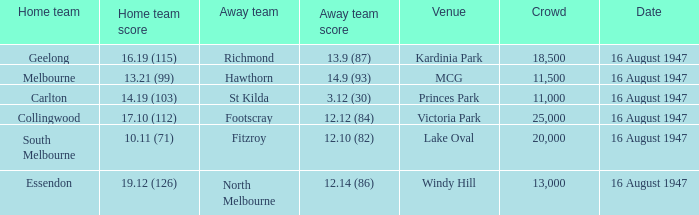What home team has had a crowd bigger than 20,000? Collingwood. 